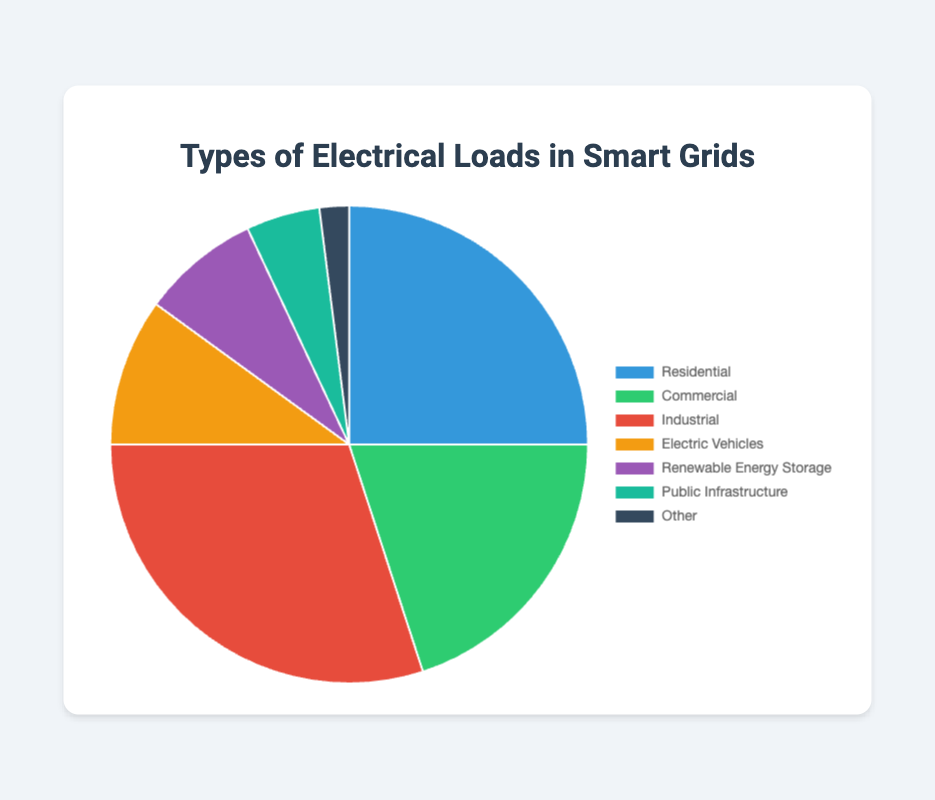What percentage of the electrical loads are accounted for by Residential, Commercial, and Industrial combined? To find the combined percentage, sum the percentages for Residential (25%), Commercial (20%), and Industrial (30%). This adds up to 25 + 20 + 30 = 75%.
Answer: 75% Which type of electrical load accounts for the highest percentage? By examining the pie chart, the type with the largest segment visually is identified, which is Industrial with 30%.
Answer: Industrial Which category has the smallest contribution to the electrical loads in smart grids? The smallest segment in the pie chart is identified visually, which is the "Other" category at 2%.
Answer: Other How do the percentages for Renewable Energy Storage and Public Infrastructure compare to the overall percentage for Electric Vehicles? Renewable Energy Storage and Public Infrastructure combined are 8% + 5% = 13%, which is greater than the percentage for Electric Vehicles at 10%.
Answer: 13% > 10% What is the difference in percentage between Industrial and Commercial loads? Subtract the percentage for Commercial (20%) from Industrial (30%): 30 - 20 = 10.
Answer: 10% If we combined Electric Vehicles and Renewable Energy Storage, what percentage of the total electrical loads would they represent? Sum the percentages for Electric Vehicles (10%) and Renewable Energy Storage (8%): 10 + 8 = 18%.
Answer: 18% Compare the contributions of Residential and Electric Vehicles to the total electrical load. Which is greater and by how much? Residential is 25%, and Electric Vehicles is 10%. The difference is 25 - 10 = 15%. Residential is greater by 15%.
Answer: Residential by 15% Which types of electrical loads collectively make up less than a quarter of the total load? Public Infrastructure (5%) + Other (2%) + Renewable Energy Storage (8%) + Electric Vehicles (10%) = 25%. Loads that individually make less than 25% are Public Infrastructure, Other, Renewable Energy Storage, and Electric Vehicles.
Answer: Public Infrastructure, Other, Renewable Energy Storage, and Electric Vehicles If the percentage for Industrial loads decreased by 5%, what would be the new percentage? Subtract 5% from the current Industrial load (30%): 30 - 5 = 25%.
Answer: 25% What is the visual color representing the Commercial load, and what is its percentage? The segment for Commercial is observed visually as green, and the corresponding percentage from the chart is 20%.
Answer: Green, 20% 